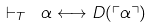Convert formula to latex. <formula><loc_0><loc_0><loc_500><loc_500>\vdash _ { T } \ \alpha \longleftrightarrow D ( \ulcorner \alpha \urcorner )</formula> 